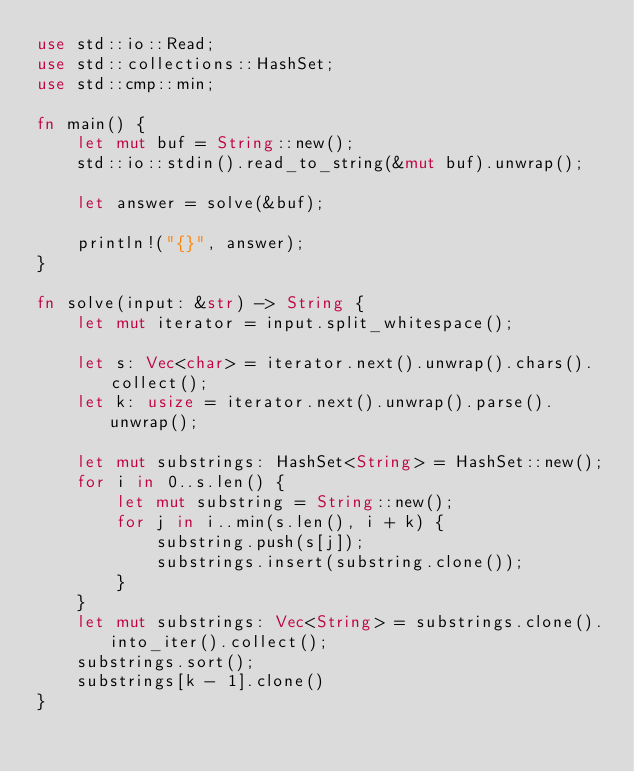Convert code to text. <code><loc_0><loc_0><loc_500><loc_500><_Rust_>use std::io::Read;
use std::collections::HashSet;
use std::cmp::min;

fn main() {
    let mut buf = String::new();
    std::io::stdin().read_to_string(&mut buf).unwrap();

    let answer = solve(&buf);

    println!("{}", answer);
}

fn solve(input: &str) -> String {
    let mut iterator = input.split_whitespace();

    let s: Vec<char> = iterator.next().unwrap().chars().collect();
    let k: usize = iterator.next().unwrap().parse().unwrap();

    let mut substrings: HashSet<String> = HashSet::new();
    for i in 0..s.len() {
        let mut substring = String::new();
        for j in i..min(s.len(), i + k) {
            substring.push(s[j]);
            substrings.insert(substring.clone());
        }
    }
    let mut substrings: Vec<String> = substrings.clone().into_iter().collect();
    substrings.sort();
    substrings[k - 1].clone()
}
</code> 